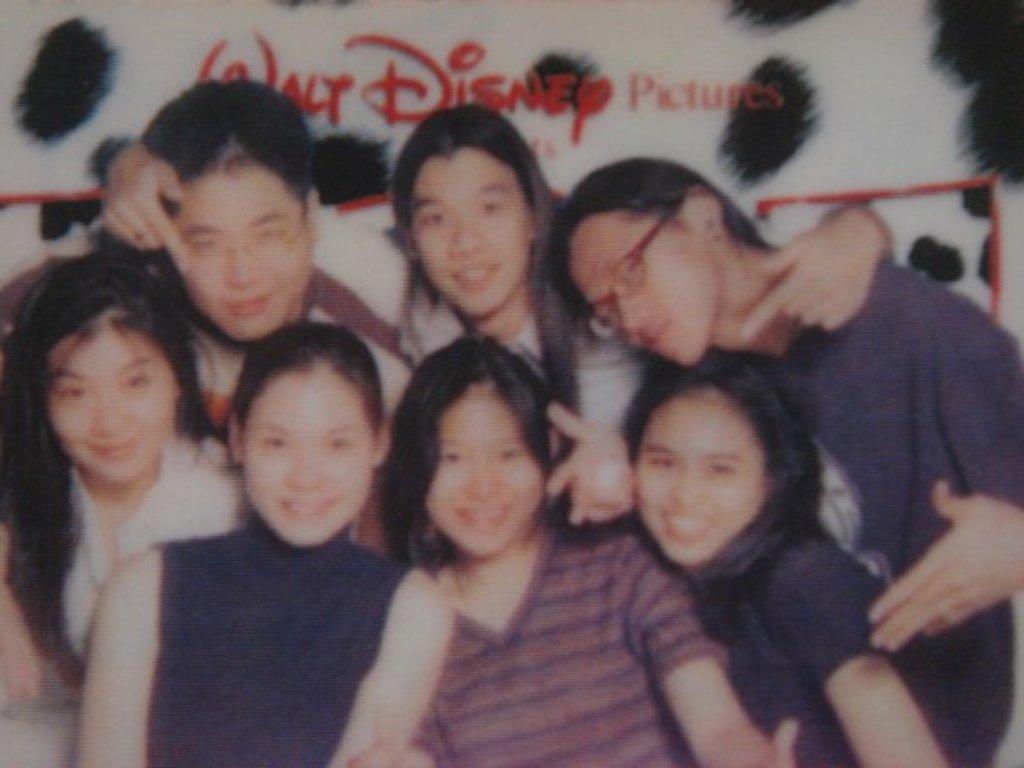Describe this image in one or two sentences. In the image in the center we can see one picture. In picture,we can see few peoples were smiling,which we can see on their faces. In the background there is a wall and we can see something written on it. 